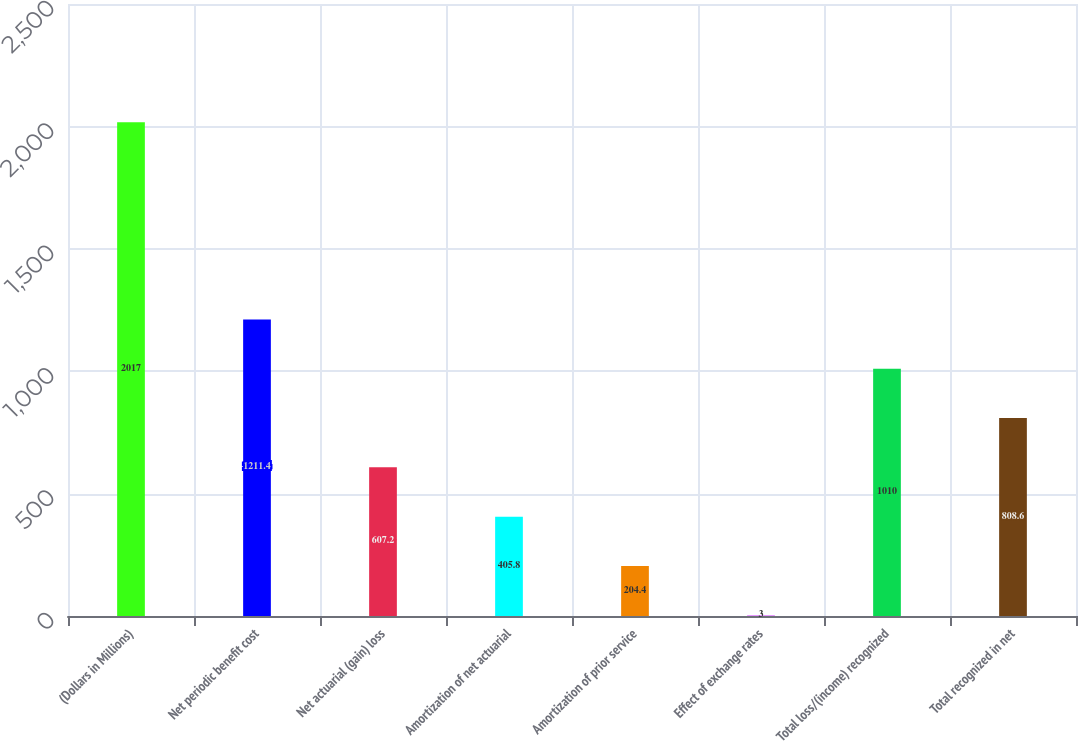Convert chart. <chart><loc_0><loc_0><loc_500><loc_500><bar_chart><fcel>(Dollars in Millions)<fcel>Net periodic benefit cost<fcel>Net actuarial (gain) loss<fcel>Amortization of net actuarial<fcel>Amortization of prior service<fcel>Effect of exchange rates<fcel>Total loss/(income) recognized<fcel>Total recognized in net<nl><fcel>2017<fcel>1211.4<fcel>607.2<fcel>405.8<fcel>204.4<fcel>3<fcel>1010<fcel>808.6<nl></chart> 